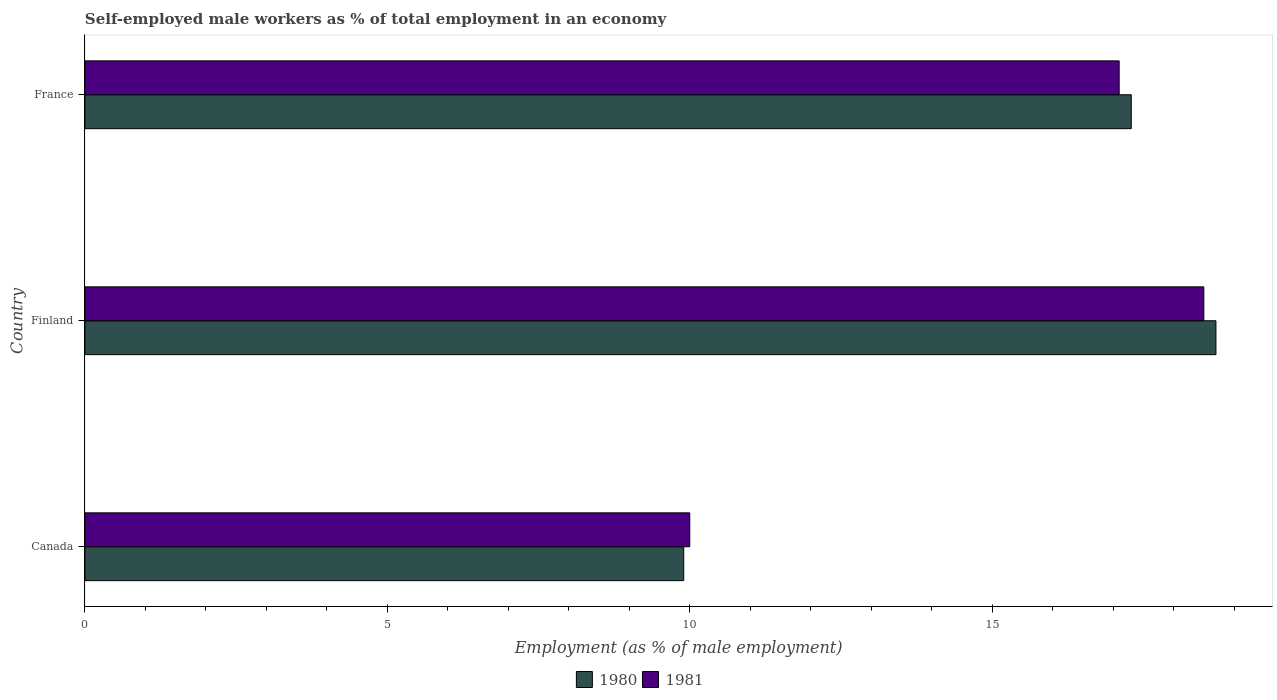How many bars are there on the 1st tick from the top?
Keep it short and to the point. 2. What is the percentage of self-employed male workers in 1981 in France?
Keep it short and to the point. 17.1. Across all countries, what is the maximum percentage of self-employed male workers in 1980?
Provide a succinct answer. 18.7. In which country was the percentage of self-employed male workers in 1980 maximum?
Your answer should be compact. Finland. In which country was the percentage of self-employed male workers in 1981 minimum?
Your answer should be compact. Canada. What is the total percentage of self-employed male workers in 1981 in the graph?
Offer a terse response. 45.6. What is the difference between the percentage of self-employed male workers in 1981 in Canada and that in Finland?
Offer a very short reply. -8.5. What is the difference between the percentage of self-employed male workers in 1981 in Canada and the percentage of self-employed male workers in 1980 in France?
Your answer should be very brief. -7.3. What is the average percentage of self-employed male workers in 1981 per country?
Offer a terse response. 15.2. What is the difference between the percentage of self-employed male workers in 1981 and percentage of self-employed male workers in 1980 in France?
Give a very brief answer. -0.2. What is the ratio of the percentage of self-employed male workers in 1981 in Canada to that in Finland?
Provide a succinct answer. 0.54. Is the percentage of self-employed male workers in 1981 in Canada less than that in Finland?
Provide a succinct answer. Yes. Is the difference between the percentage of self-employed male workers in 1981 in Canada and Finland greater than the difference between the percentage of self-employed male workers in 1980 in Canada and Finland?
Your answer should be very brief. Yes. What is the difference between the highest and the second highest percentage of self-employed male workers in 1981?
Your answer should be compact. 1.4. What is the difference between the highest and the lowest percentage of self-employed male workers in 1981?
Your answer should be compact. 8.5. In how many countries, is the percentage of self-employed male workers in 1980 greater than the average percentage of self-employed male workers in 1980 taken over all countries?
Offer a terse response. 2. Are the values on the major ticks of X-axis written in scientific E-notation?
Your response must be concise. No. Does the graph contain any zero values?
Ensure brevity in your answer.  No. Does the graph contain grids?
Make the answer very short. No. What is the title of the graph?
Offer a very short reply. Self-employed male workers as % of total employment in an economy. Does "1962" appear as one of the legend labels in the graph?
Keep it short and to the point. No. What is the label or title of the X-axis?
Make the answer very short. Employment (as % of male employment). What is the label or title of the Y-axis?
Ensure brevity in your answer.  Country. What is the Employment (as % of male employment) of 1980 in Canada?
Your answer should be very brief. 9.9. What is the Employment (as % of male employment) of 1980 in Finland?
Ensure brevity in your answer.  18.7. What is the Employment (as % of male employment) in 1981 in Finland?
Provide a short and direct response. 18.5. What is the Employment (as % of male employment) in 1980 in France?
Provide a short and direct response. 17.3. What is the Employment (as % of male employment) of 1981 in France?
Ensure brevity in your answer.  17.1. Across all countries, what is the maximum Employment (as % of male employment) in 1980?
Your answer should be compact. 18.7. Across all countries, what is the maximum Employment (as % of male employment) in 1981?
Offer a very short reply. 18.5. Across all countries, what is the minimum Employment (as % of male employment) of 1980?
Give a very brief answer. 9.9. What is the total Employment (as % of male employment) of 1980 in the graph?
Offer a very short reply. 45.9. What is the total Employment (as % of male employment) in 1981 in the graph?
Your answer should be very brief. 45.6. What is the difference between the Employment (as % of male employment) of 1980 in Canada and that in Finland?
Give a very brief answer. -8.8. What is the difference between the Employment (as % of male employment) of 1980 in Canada and that in France?
Offer a terse response. -7.4. What is the difference between the Employment (as % of male employment) in 1981 in Finland and that in France?
Your answer should be very brief. 1.4. What is the difference between the Employment (as % of male employment) in 1980 in Canada and the Employment (as % of male employment) in 1981 in France?
Your response must be concise. -7.2. What is the difference between the Employment (as % of male employment) in 1980 in Finland and the Employment (as % of male employment) in 1981 in France?
Offer a terse response. 1.6. What is the difference between the Employment (as % of male employment) in 1980 and Employment (as % of male employment) in 1981 in France?
Your answer should be very brief. 0.2. What is the ratio of the Employment (as % of male employment) of 1980 in Canada to that in Finland?
Provide a short and direct response. 0.53. What is the ratio of the Employment (as % of male employment) of 1981 in Canada to that in Finland?
Give a very brief answer. 0.54. What is the ratio of the Employment (as % of male employment) of 1980 in Canada to that in France?
Provide a succinct answer. 0.57. What is the ratio of the Employment (as % of male employment) of 1981 in Canada to that in France?
Keep it short and to the point. 0.58. What is the ratio of the Employment (as % of male employment) of 1980 in Finland to that in France?
Your answer should be very brief. 1.08. What is the ratio of the Employment (as % of male employment) of 1981 in Finland to that in France?
Give a very brief answer. 1.08. What is the difference between the highest and the second highest Employment (as % of male employment) of 1981?
Keep it short and to the point. 1.4. What is the difference between the highest and the lowest Employment (as % of male employment) of 1981?
Make the answer very short. 8.5. 